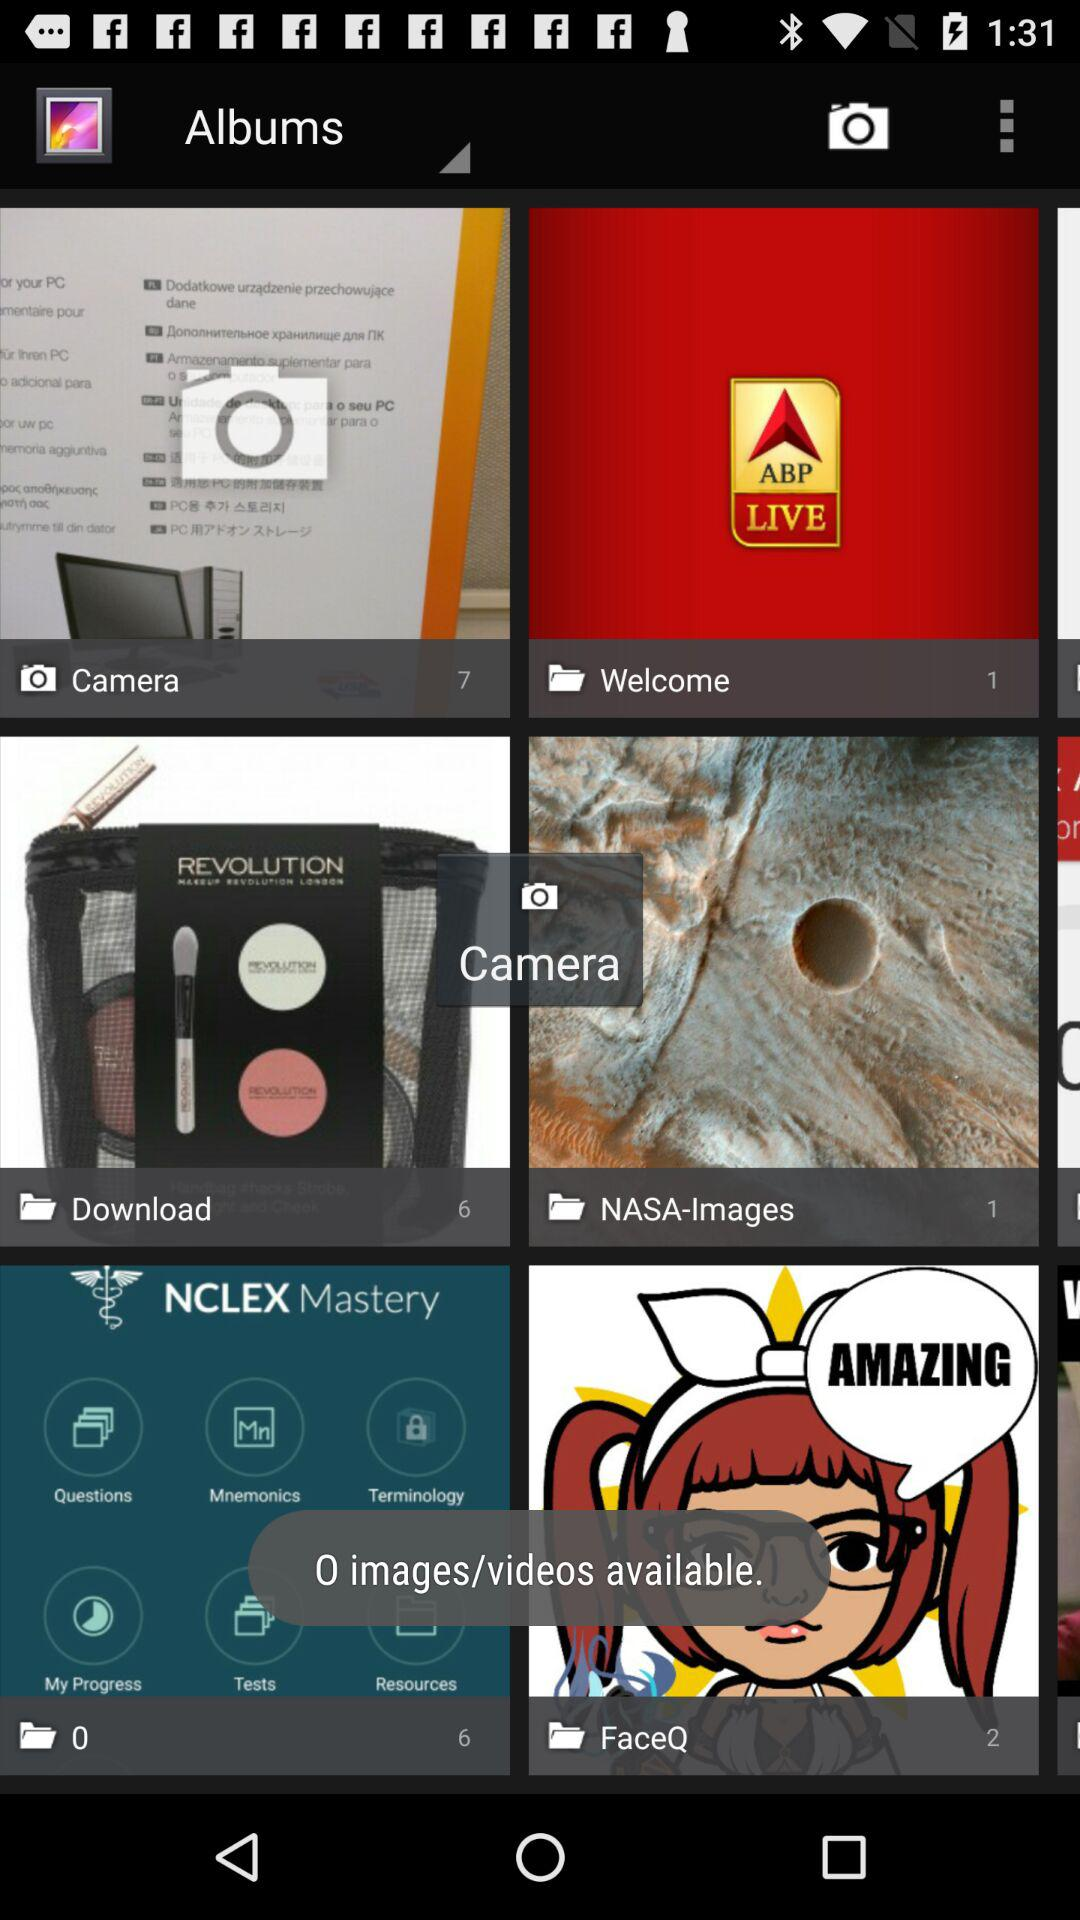What number of pictures are shown in the welcome folder? The picture in the welcome folder is 1. 